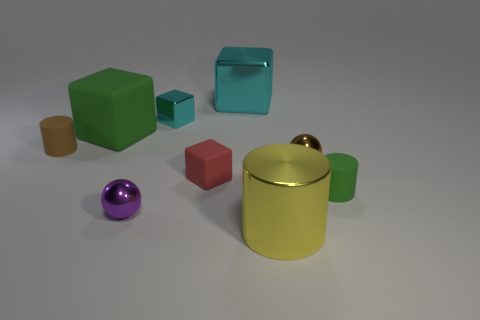What is the color of the cylinder that is made of the same material as the large cyan cube?
Your answer should be very brief. Yellow. Is the color of the big cylinder the same as the small rubber cylinder that is left of the big cyan block?
Make the answer very short. No. What is the color of the thing that is both in front of the big green cube and to the left of the tiny purple metal ball?
Provide a short and direct response. Brown. What number of tiny purple objects are behind the large matte block?
Keep it short and to the point. 0. What number of things are red rubber things or cylinders on the right side of the purple thing?
Provide a succinct answer. 3. There is a small cylinder that is right of the large cyan object; are there any balls behind it?
Make the answer very short. Yes. There is a tiny shiny thing that is right of the red cube; what color is it?
Your answer should be very brief. Brown. Are there an equal number of red objects to the right of the tiny green rubber cylinder and big blue shiny cylinders?
Make the answer very short. Yes. What is the shape of the metallic object that is on the left side of the big metal cylinder and in front of the tiny brown metal ball?
Give a very brief answer. Sphere. There is another small thing that is the same shape as the purple metal thing; what color is it?
Offer a terse response. Brown. 